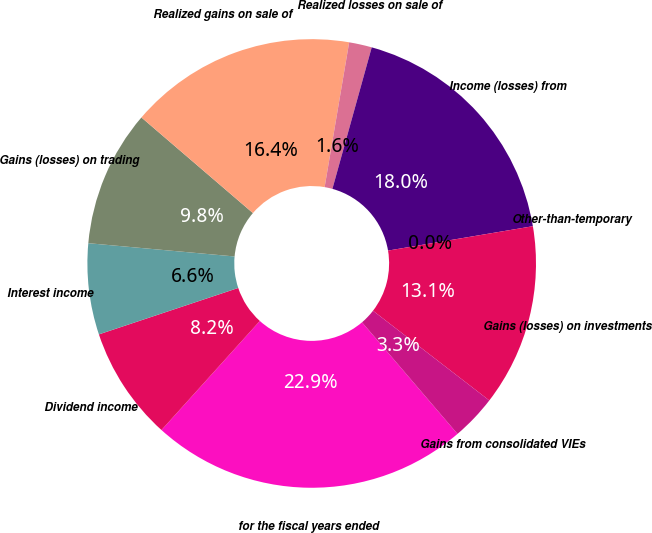Convert chart. <chart><loc_0><loc_0><loc_500><loc_500><pie_chart><fcel>for the fiscal years ended<fcel>Dividend income<fcel>Interest income<fcel>Gains (losses) on trading<fcel>Realized gains on sale of<fcel>Realized losses on sale of<fcel>Income (losses) from<fcel>Other-than-temporary<fcel>Gains (losses) on investments<fcel>Gains from consolidated VIEs<nl><fcel>22.94%<fcel>8.2%<fcel>6.56%<fcel>9.84%<fcel>16.39%<fcel>1.64%<fcel>18.03%<fcel>0.0%<fcel>13.11%<fcel>3.28%<nl></chart> 